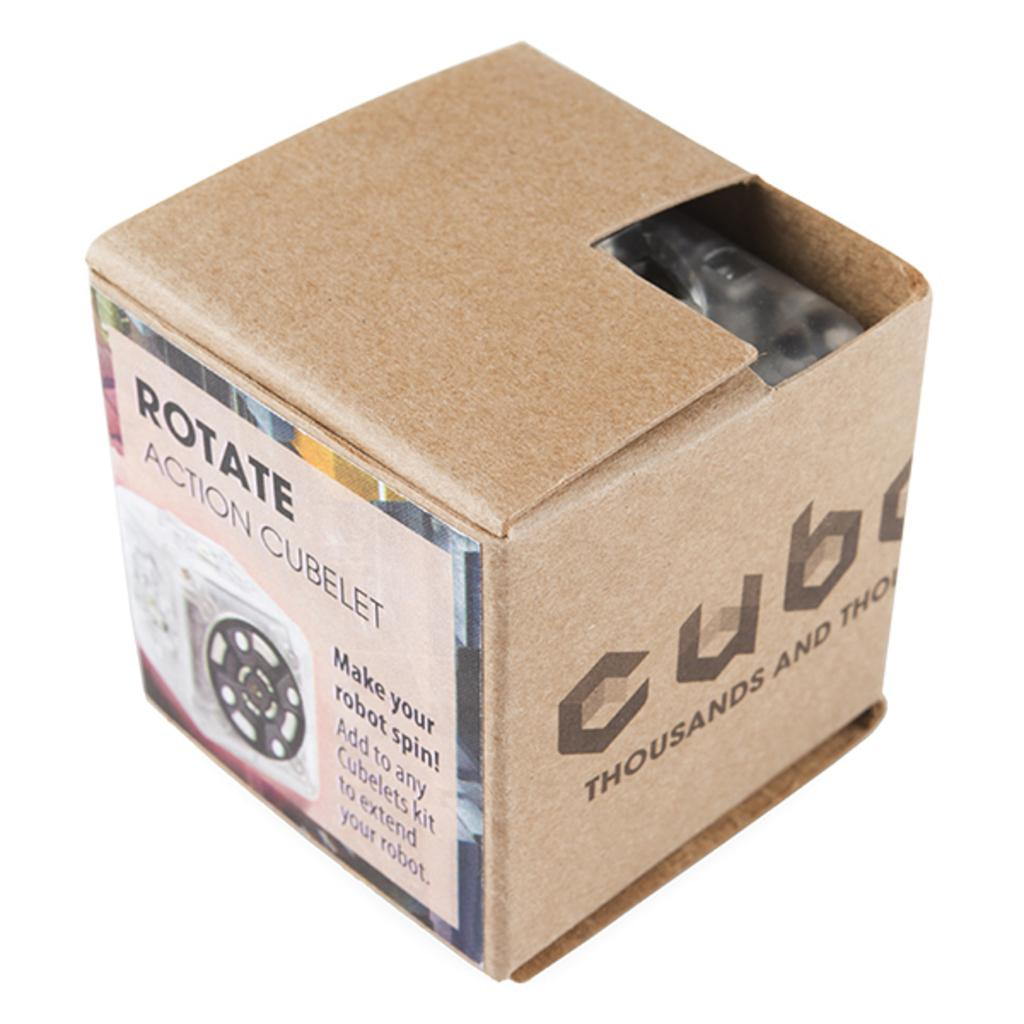<image>
Give a short and clear explanation of the subsequent image. a box for Rotate Action Cubelet with a part of the top cut off 